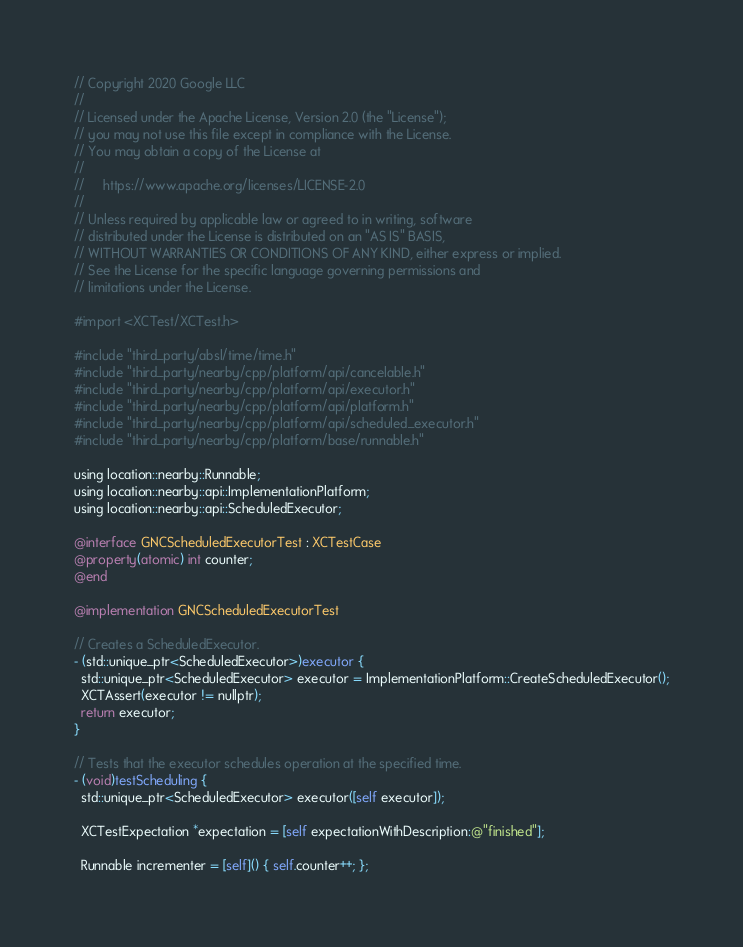Convert code to text. <code><loc_0><loc_0><loc_500><loc_500><_ObjectiveC_>// Copyright 2020 Google LLC
//
// Licensed under the Apache License, Version 2.0 (the "License");
// you may not use this file except in compliance with the License.
// You may obtain a copy of the License at
//
//     https://www.apache.org/licenses/LICENSE-2.0
//
// Unless required by applicable law or agreed to in writing, software
// distributed under the License is distributed on an "AS IS" BASIS,
// WITHOUT WARRANTIES OR CONDITIONS OF ANY KIND, either express or implied.
// See the License for the specific language governing permissions and
// limitations under the License.

#import <XCTest/XCTest.h>

#include "third_party/absl/time/time.h"
#include "third_party/nearby/cpp/platform/api/cancelable.h"
#include "third_party/nearby/cpp/platform/api/executor.h"
#include "third_party/nearby/cpp/platform/api/platform.h"
#include "third_party/nearby/cpp/platform/api/scheduled_executor.h"
#include "third_party/nearby/cpp/platform/base/runnable.h"

using location::nearby::Runnable;
using location::nearby::api::ImplementationPlatform;
using location::nearby::api::ScheduledExecutor;

@interface GNCScheduledExecutorTest : XCTestCase
@property(atomic) int counter;
@end

@implementation GNCScheduledExecutorTest

// Creates a ScheduledExecutor.
- (std::unique_ptr<ScheduledExecutor>)executor {
  std::unique_ptr<ScheduledExecutor> executor = ImplementationPlatform::CreateScheduledExecutor();
  XCTAssert(executor != nullptr);
  return executor;
}

// Tests that the executor schedules operation at the specified time.
- (void)testScheduling {
  std::unique_ptr<ScheduledExecutor> executor([self executor]);

  XCTestExpectation *expectation = [self expectationWithDescription:@"finished"];

  Runnable incrementer = [self]() { self.counter++; };
</code> 